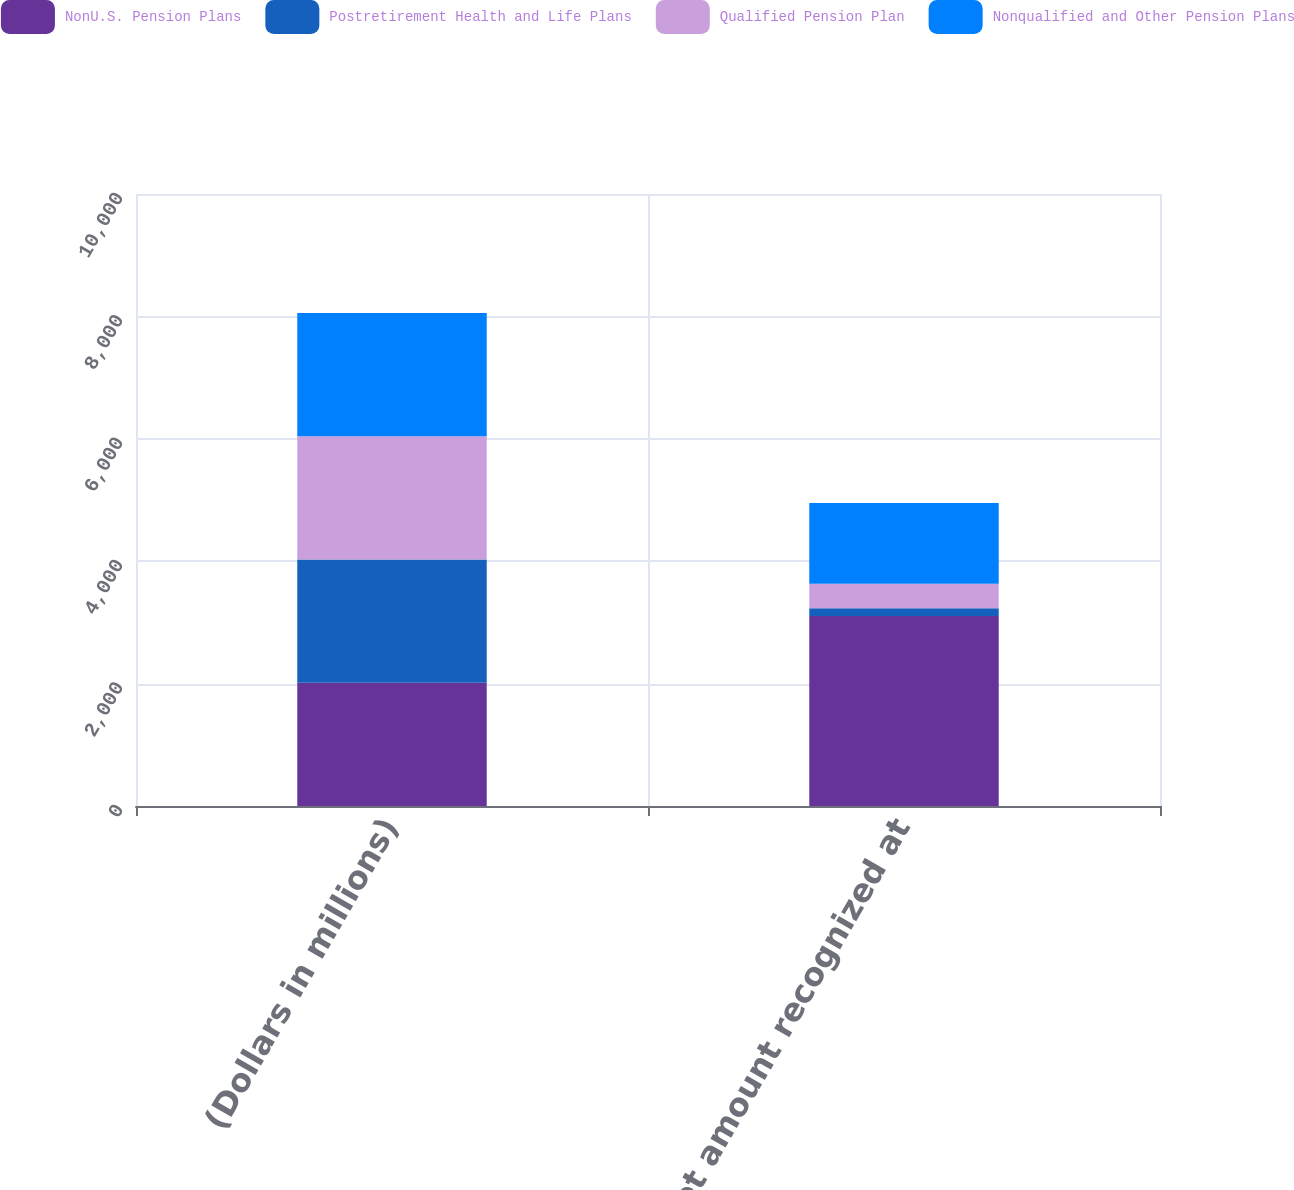Convert chart. <chart><loc_0><loc_0><loc_500><loc_500><stacked_bar_chart><ecel><fcel>(Dollars in millions)<fcel>Net amount recognized at<nl><fcel>NonU.S. Pension Plans<fcel>2014<fcel>3106<nl><fcel>Postretirement Health and Life Plans<fcel>2014<fcel>124<nl><fcel>Qualified Pension Plan<fcel>2014<fcel>402<nl><fcel>Nonqualified and Other Pension Plans<fcel>2014<fcel>1318<nl></chart> 